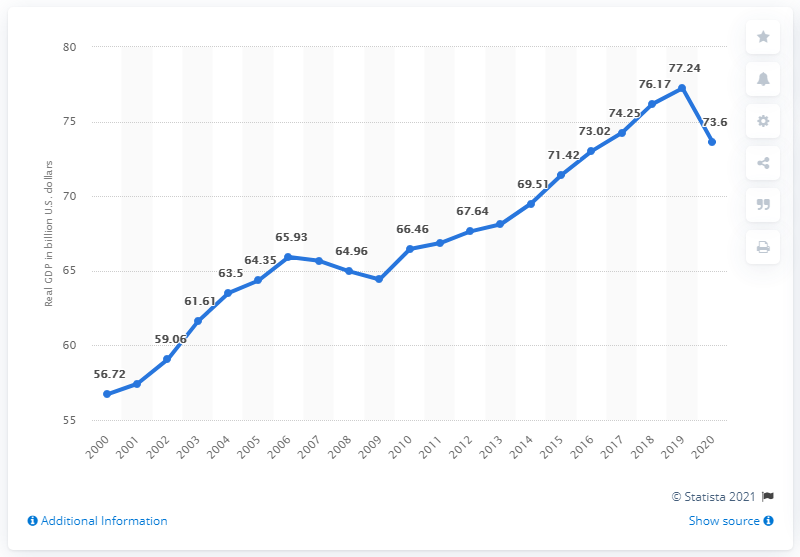Highlight a few significant elements in this photo. In the previous year, the Gross Domestic Product (GDP) of New Hampshire was $73.6 billion dollars. The average of the real GDP for the years 2016 to 2020 minus the median of the same data is equal to 0.642. The Gross Domestic Product of New Hampshire in 2020 was 73.6 billion dollars. The median value of the last three data points is 77.24. 